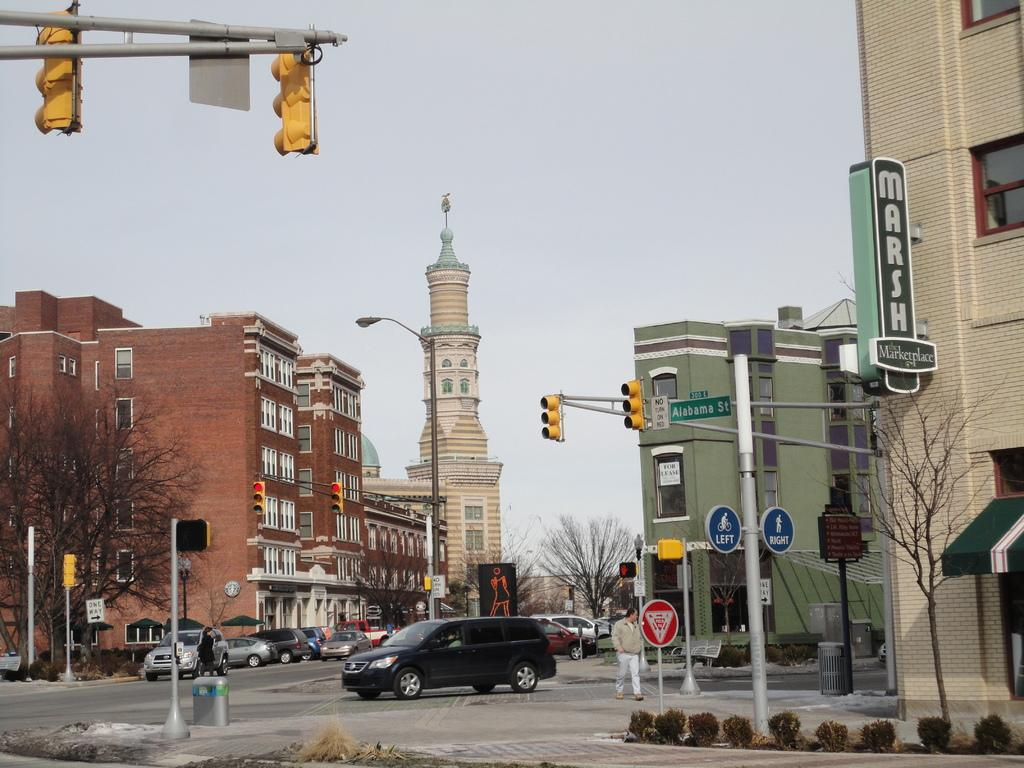<image>
Create a compact narrative representing the image presented. A street view of a Marketplace named "MARSH". 